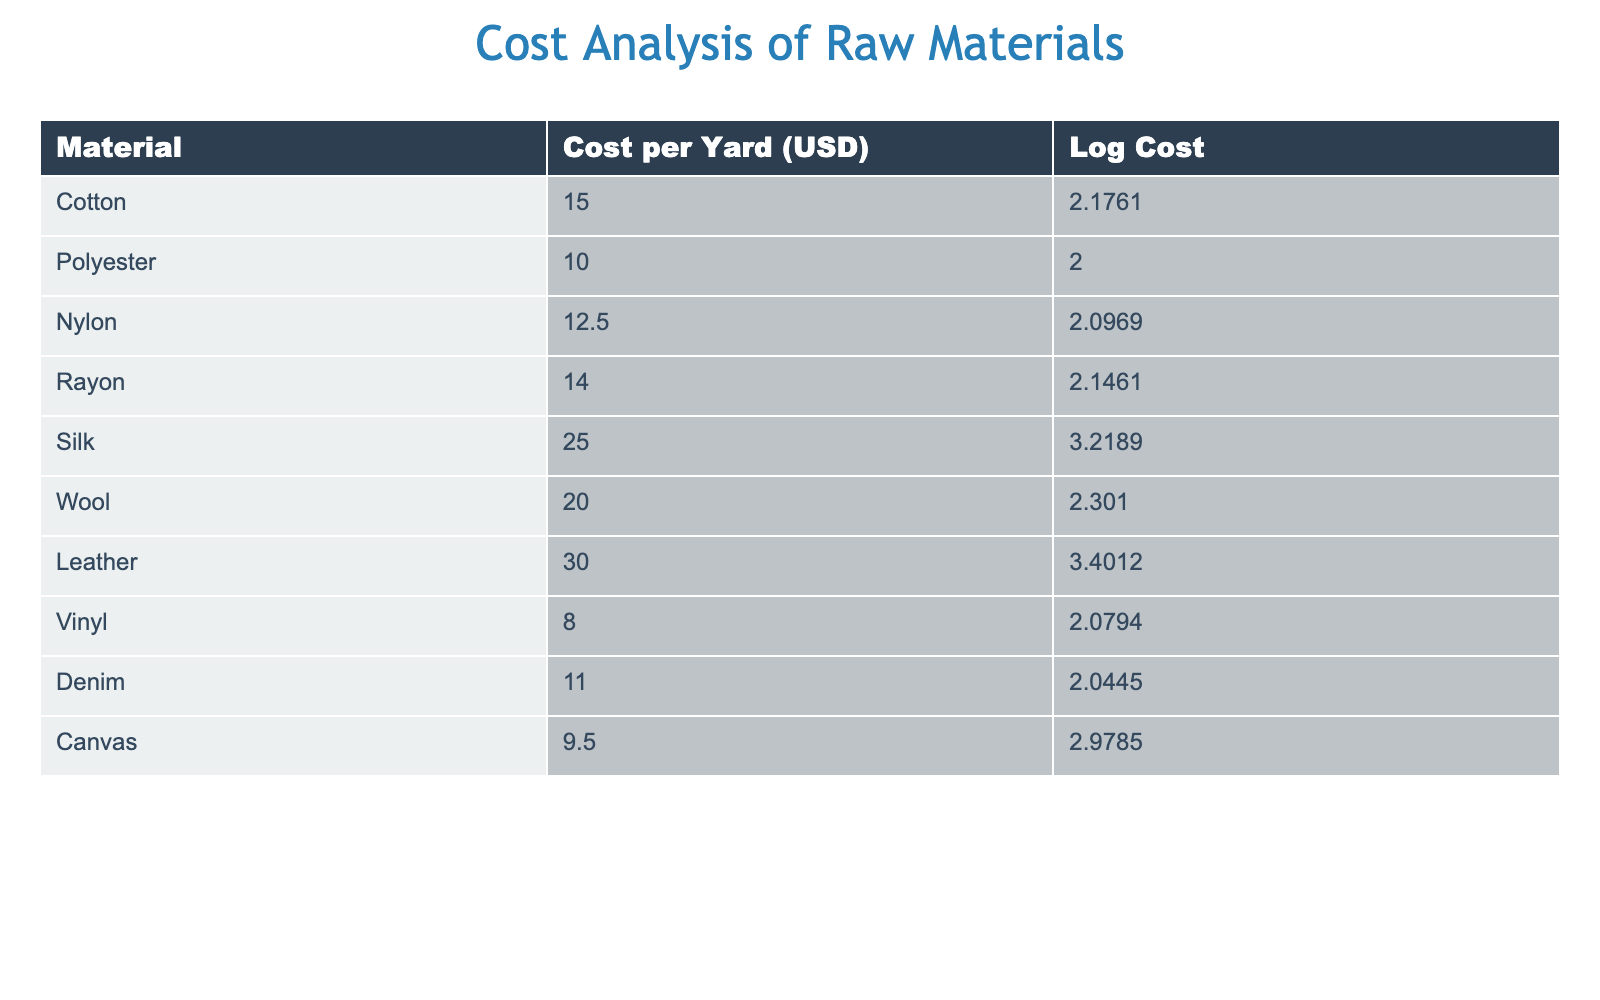What is the cost per yard of silk? The table lists the cost per yard of various materials. Silk is specifically noted in the "Cost per Yard (USD)" column. Referring to the row for silk, the cost is 25.00.
Answer: 25.00 What is the log cost of nylon? Looking at the row corresponding to nylon in the table, the "Log Cost" column indicates the log cost of nylon is 2.0969.
Answer: 2.0969 Which material has the highest cost per yard? The "Cost per Yard (USD)" column must be scanned to find the highest value. Leather has the highest value at 30.00 USD per yard.
Answer: Leather What is the average cost per yard of all materials listed? To find the average, we sum all the costs: 15.00 + 10.00 + 12.50 + 14.00 + 25.00 + 20.00 + 30.00 + 8.00 + 11.00 + 9.50 =  150.00. There are 10 materials, so dividing gives an average cost of 150.00 / 10 = 15.00.
Answer: 15.00 Is the cost of denim higher than that of vinyl? The cost per yard for denim is 11.00 and for vinyl is 8.00. Since 11.00 is greater than 8.00, the statement is true.
Answer: Yes What is the difference in cost per yard between silk and leather? The cost per yard for silk is 25.00 and for leather is 30.00. The difference is calculated as 30.00 - 25.00 = 5.00.
Answer: 5.00 Which material represents the lowest cost in the log cost column? By checking the "Log Cost" column, we find that polyester has the lowest log cost of 2.0000.
Answer: Polyester If the costs of wool and cotton are added together, do they exceed the cost of leather? Wool costs 20.00 and cotton costs 15.00. Their combined cost is 20.00 + 15.00 = 35.00, which is greater than leather's cost of 30.00. Therefore, yes, the combined cost exceeds leather's cost.
Answer: Yes 